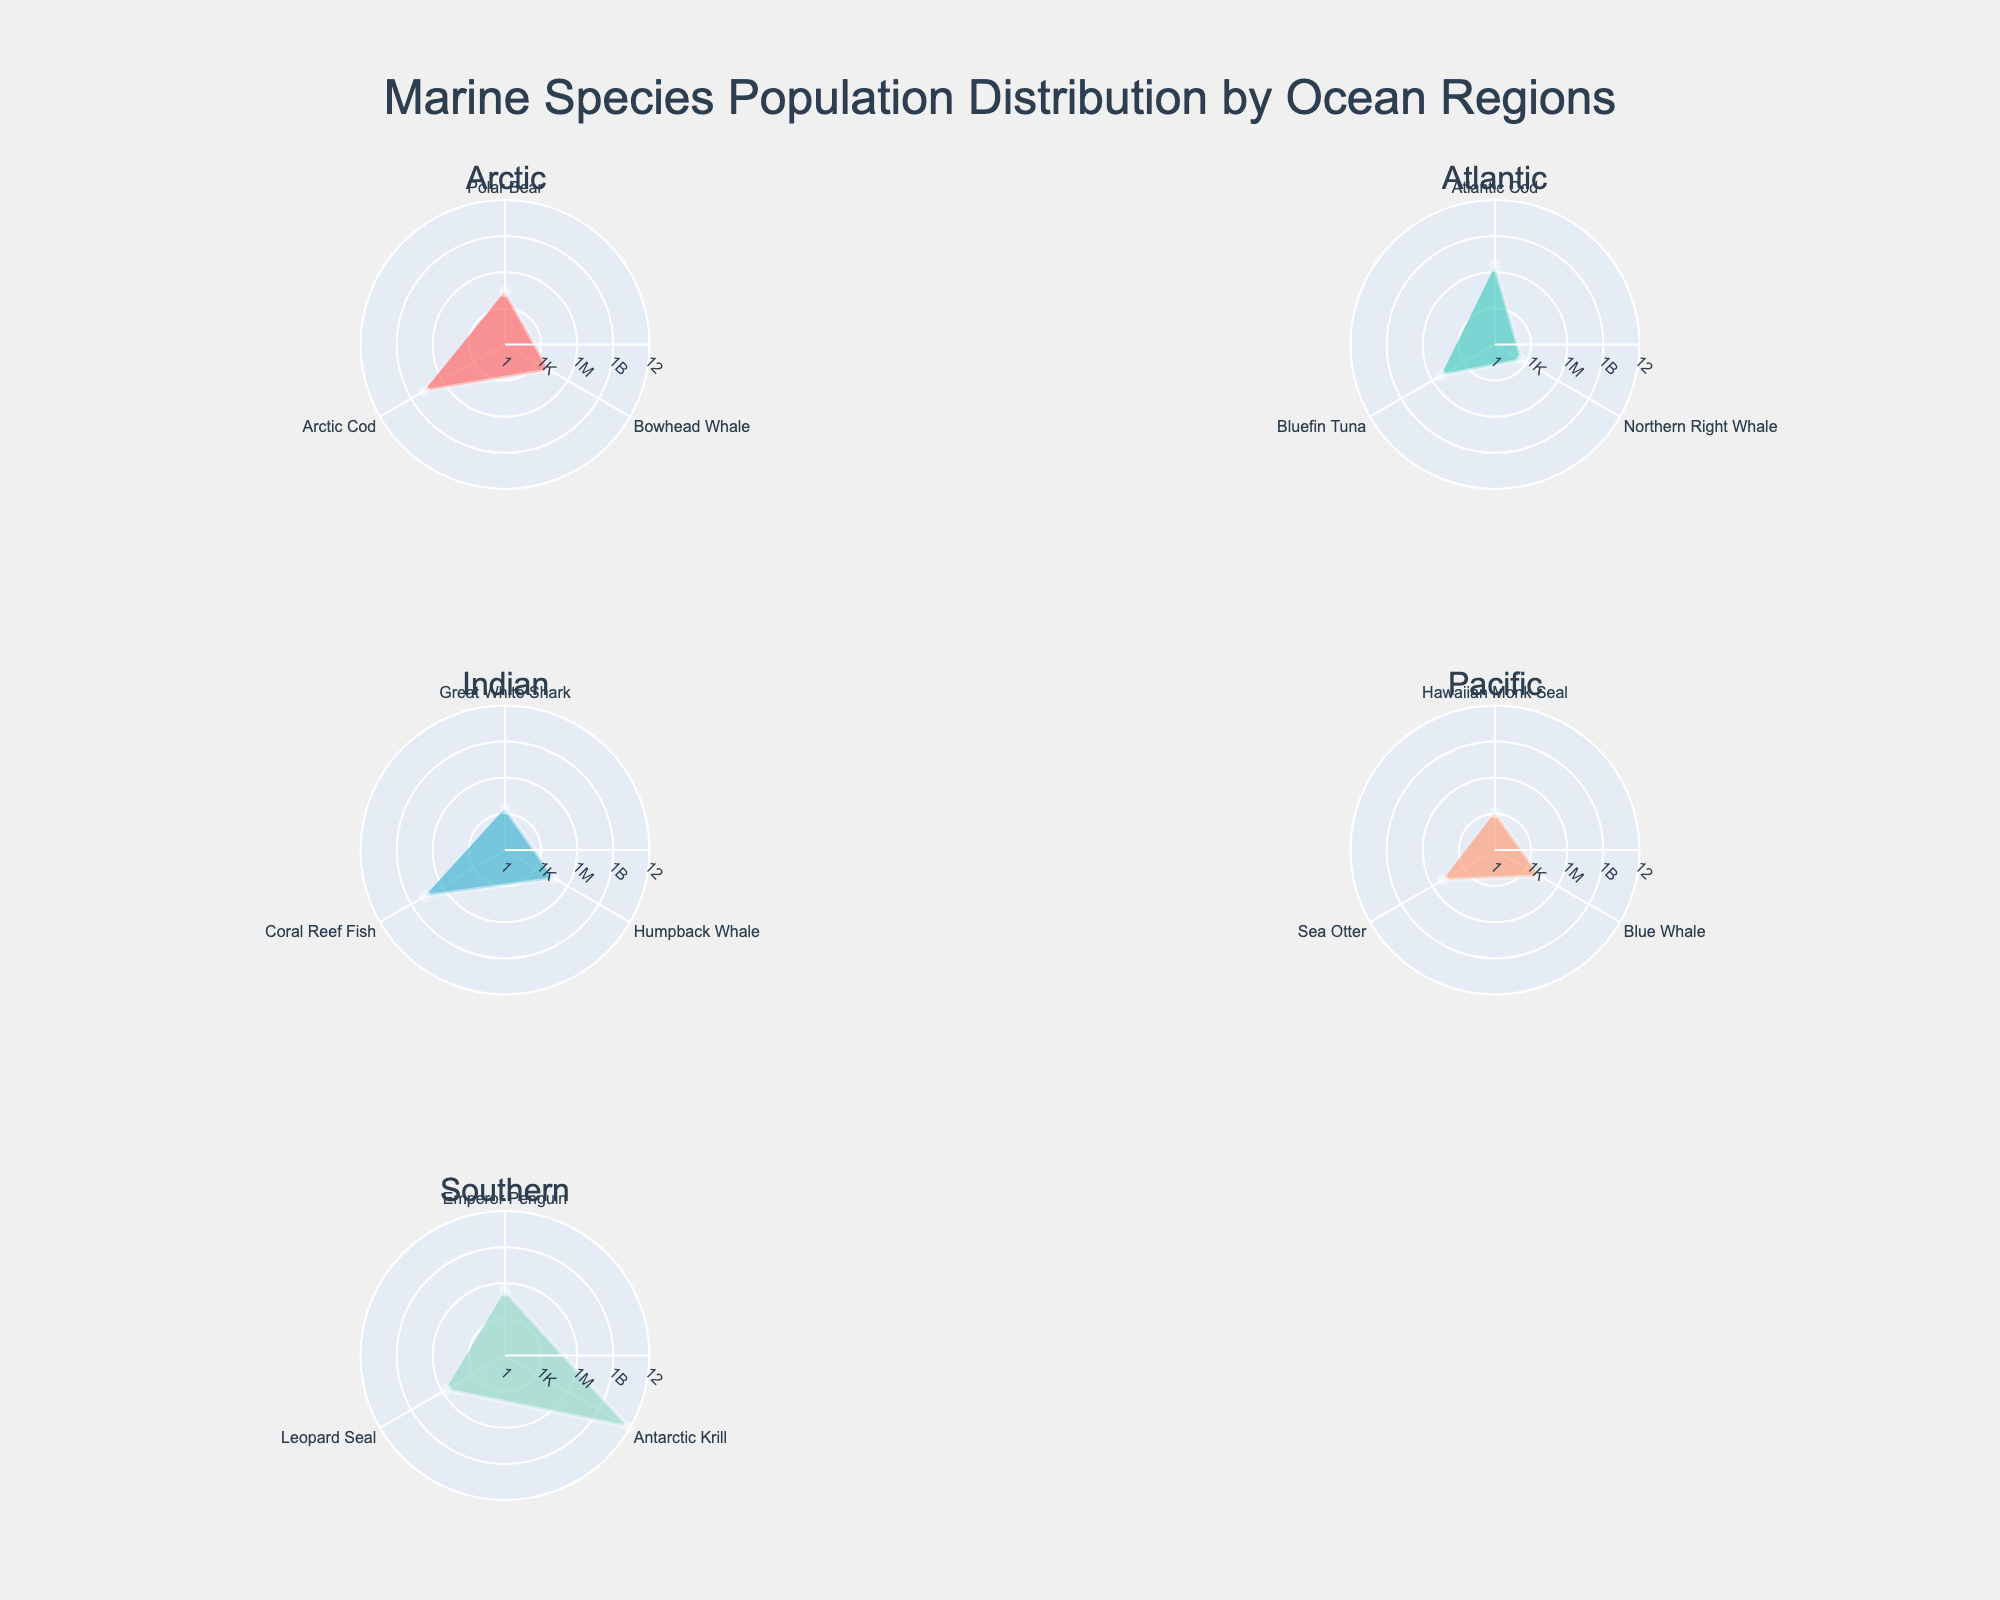What's the title of the figure? The title is usually placed at the top of the figure and is meant to summarize what the figure is about. In this figure, the title reads "Marine Species Population Distribution by Ocean Regions".
Answer: Marine Species Population Distribution by Ocean Regions How many regions are shown in the figure? By looking at the subplot titles in the figure, we can count that there are five unique ocean regions represented. The regions are Arctic, Atlantic, Indian, Pacific, and Southern.
Answer: Five Which species in the Arctic region has the highest population? By observing the Arctic subplot, we see that Arctic Cod has the largest radial distance, indicating it has the highest population.
Answer: Arctic Cod Which region has the highest variation in species population? To determine this, we visually assess the spread of radial distances for different regions. The Southern region shows the widest range of radial distances, from Antarctic Krill with the highest to other species with much lower populations.
Answer: Southern What is the population difference between the Atlantic Cod and the Bluefin Tuna in the Atlantic region? In the Atlantic region subplot, Atlantic Cod has a population represented by a radial distance corresponding to 3.3 million, while Bluefin Tuna corresponds to 150,000. The difference is obtained by subtracting 150,000 from 3,300,000.
Answer: 3,150,000 Which region has the least number of species represented in the figure? By counting the distinct species listed in each region, we can see that both the Arctic and Pacific regions have three species each, which is less than the other regions.
Answer: Arctic and Pacific Describe the distribution pattern of species in the Indian region. In the Indian region subplot, we observe that while Coral Reef Fish has the highest population, the other species like Great White Shark and Humpback Whale have significantly lower populations, indicating a skewed distribution with one dominant species.
Answer: Skewed distribution with one dominant species How does the population of Blue Whales in the Pacific region compare to the Bowhead Whales in the Arctic region? By comparing radial distances, the population of Blue Whales in the Pacific is approximately the same as Bowhead Whales in the Arctic, both represented by similar radial distances.
Answer: Approximately the same Which species has the largest population in the Southern region, and how does its population compare to the total population of all species in the Atlantic region? Antarctic Krill in the Southern region has the largest population with a radial distance indicating 800 billion. For the Atlantic region, the total population is the sum of individual populations: Atlantic Cod (3.3 million), Northern Right Whale (400), and Bluefin Tuna (150,000), which totals to approximately 3.45 million. The population of Antarctic Krill is vastly larger.
Answer: Antarctic Krill, vastly larger 